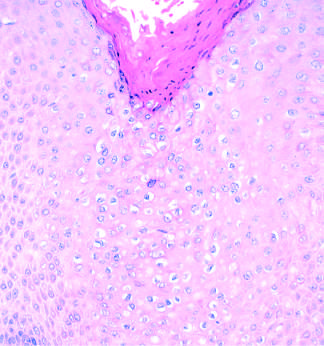what include acanthosis, hyperkeratosis, and cytoplasmic vacuolization (koilocytosis, center)?
Answer the question using a single word or phrase. Histopathologic features of condyloma acuminatum 